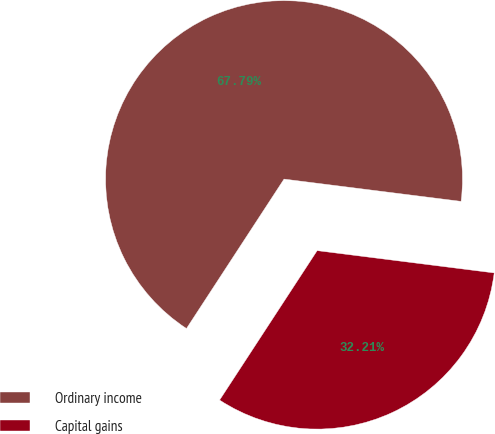Convert chart to OTSL. <chart><loc_0><loc_0><loc_500><loc_500><pie_chart><fcel>Ordinary income<fcel>Capital gains<nl><fcel>67.79%<fcel>32.21%<nl></chart> 